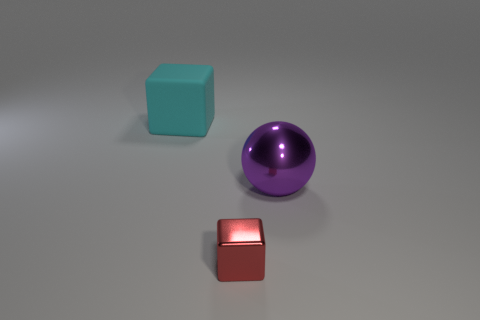What number of big rubber cubes are behind the large thing on the right side of the cube that is left of the shiny cube?
Provide a short and direct response. 1. There is a big block; does it have the same color as the metal thing that is left of the large metallic object?
Offer a terse response. No. What material is the thing left of the block in front of the big cyan thing behind the small metallic cube made of?
Offer a terse response. Rubber. Do the large thing that is to the right of the matte cube and the small red shiny thing have the same shape?
Your answer should be compact. No. There is a object that is on the left side of the tiny red block; what material is it?
Offer a terse response. Rubber. What number of shiny objects are large purple balls or tiny red things?
Your answer should be compact. 2. Is there a purple thing that has the same size as the metal ball?
Your answer should be compact. No. Are there more big metal spheres behind the ball than big purple cylinders?
Ensure brevity in your answer.  No. What number of small things are either red metal objects or brown metal cubes?
Provide a short and direct response. 1. How many big purple metal things have the same shape as the red metal thing?
Offer a terse response. 0. 